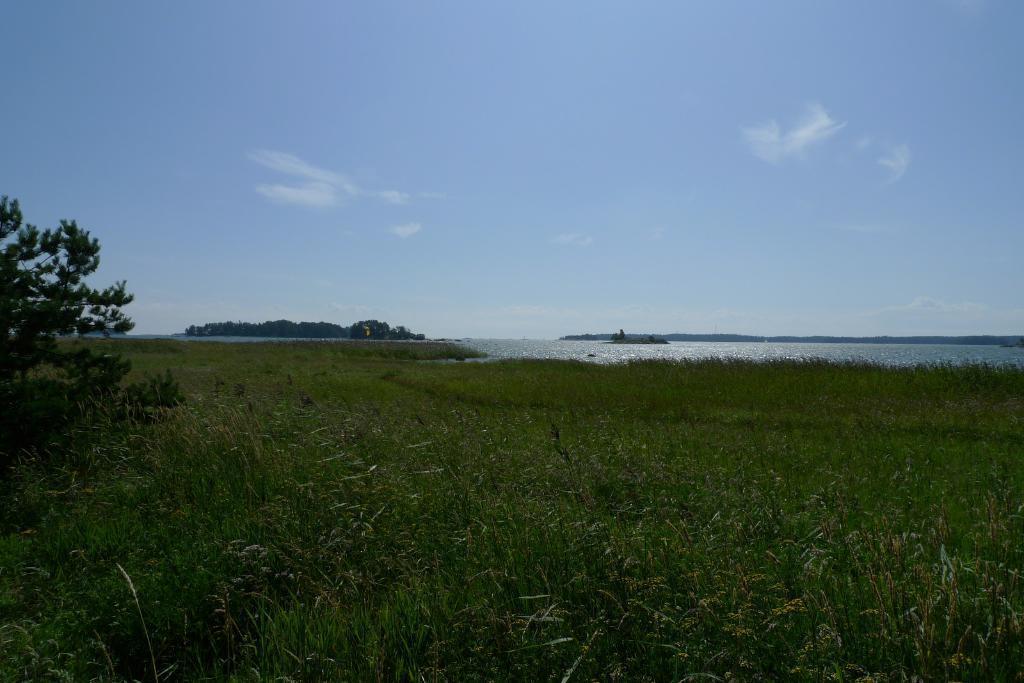In one or two sentences, can you explain what this image depicts? In this picture we can see some grass from left to right. There is a plant on the left side. We can see some greenery and water in the background. Sky is blue in color and cloudy. 